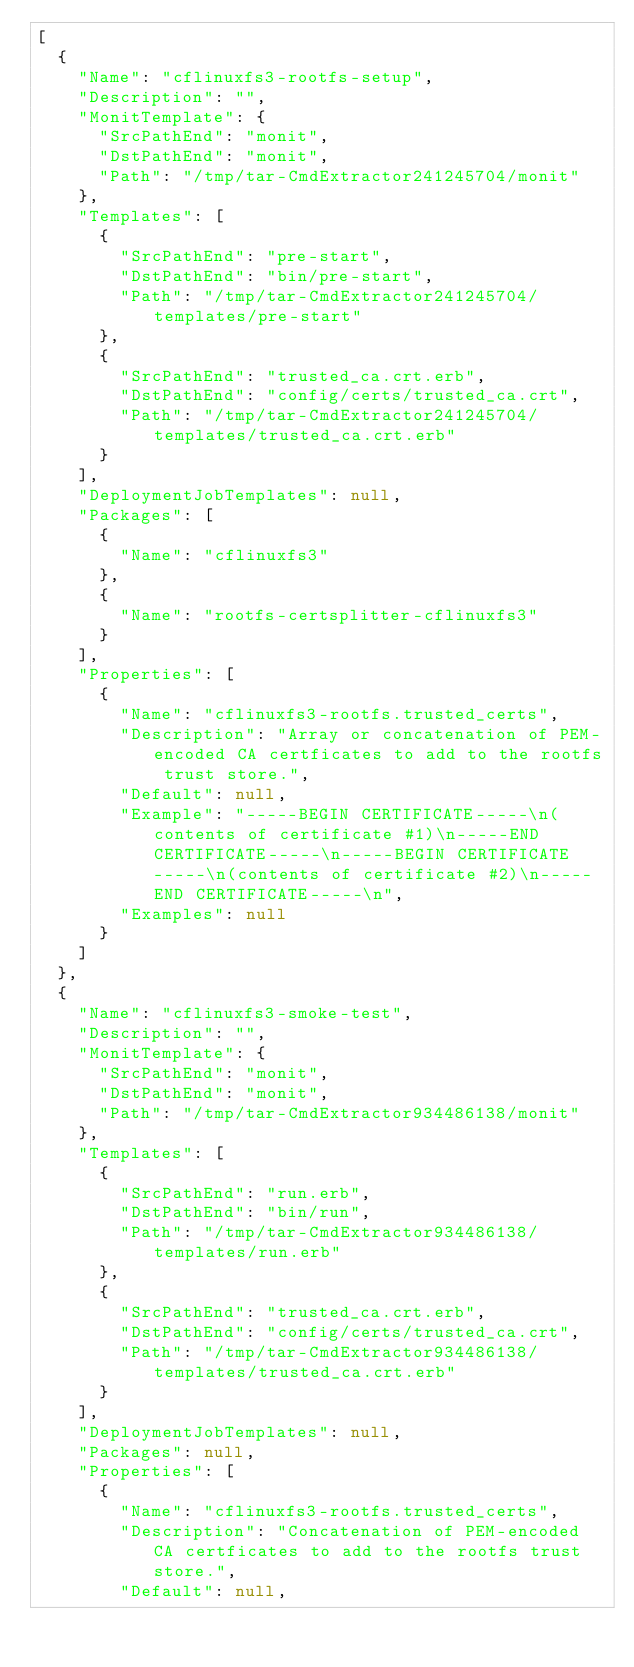<code> <loc_0><loc_0><loc_500><loc_500><_YAML_>[
  {
    "Name": "cflinuxfs3-rootfs-setup",
    "Description": "",
    "MonitTemplate": {
      "SrcPathEnd": "monit",
      "DstPathEnd": "monit",
      "Path": "/tmp/tar-CmdExtractor241245704/monit"
    },
    "Templates": [
      {
        "SrcPathEnd": "pre-start",
        "DstPathEnd": "bin/pre-start",
        "Path": "/tmp/tar-CmdExtractor241245704/templates/pre-start"
      },
      {
        "SrcPathEnd": "trusted_ca.crt.erb",
        "DstPathEnd": "config/certs/trusted_ca.crt",
        "Path": "/tmp/tar-CmdExtractor241245704/templates/trusted_ca.crt.erb"
      }
    ],
    "DeploymentJobTemplates": null,
    "Packages": [
      {
        "Name": "cflinuxfs3"
      },
      {
        "Name": "rootfs-certsplitter-cflinuxfs3"
      }
    ],
    "Properties": [
      {
        "Name": "cflinuxfs3-rootfs.trusted_certs",
        "Description": "Array or concatenation of PEM-encoded CA certficates to add to the rootfs trust store.",
        "Default": null,
        "Example": "-----BEGIN CERTIFICATE-----\n(contents of certificate #1)\n-----END CERTIFICATE-----\n-----BEGIN CERTIFICATE-----\n(contents of certificate #2)\n-----END CERTIFICATE-----\n",
        "Examples": null
      }
    ]
  },
  {
    "Name": "cflinuxfs3-smoke-test",
    "Description": "",
    "MonitTemplate": {
      "SrcPathEnd": "monit",
      "DstPathEnd": "monit",
      "Path": "/tmp/tar-CmdExtractor934486138/monit"
    },
    "Templates": [
      {
        "SrcPathEnd": "run.erb",
        "DstPathEnd": "bin/run",
        "Path": "/tmp/tar-CmdExtractor934486138/templates/run.erb"
      },
      {
        "SrcPathEnd": "trusted_ca.crt.erb",
        "DstPathEnd": "config/certs/trusted_ca.crt",
        "Path": "/tmp/tar-CmdExtractor934486138/templates/trusted_ca.crt.erb"
      }
    ],
    "DeploymentJobTemplates": null,
    "Packages": null,
    "Properties": [
      {
        "Name": "cflinuxfs3-rootfs.trusted_certs",
        "Description": "Concatenation of PEM-encoded CA certficates to add to the rootfs trust store.",
        "Default": null,</code> 